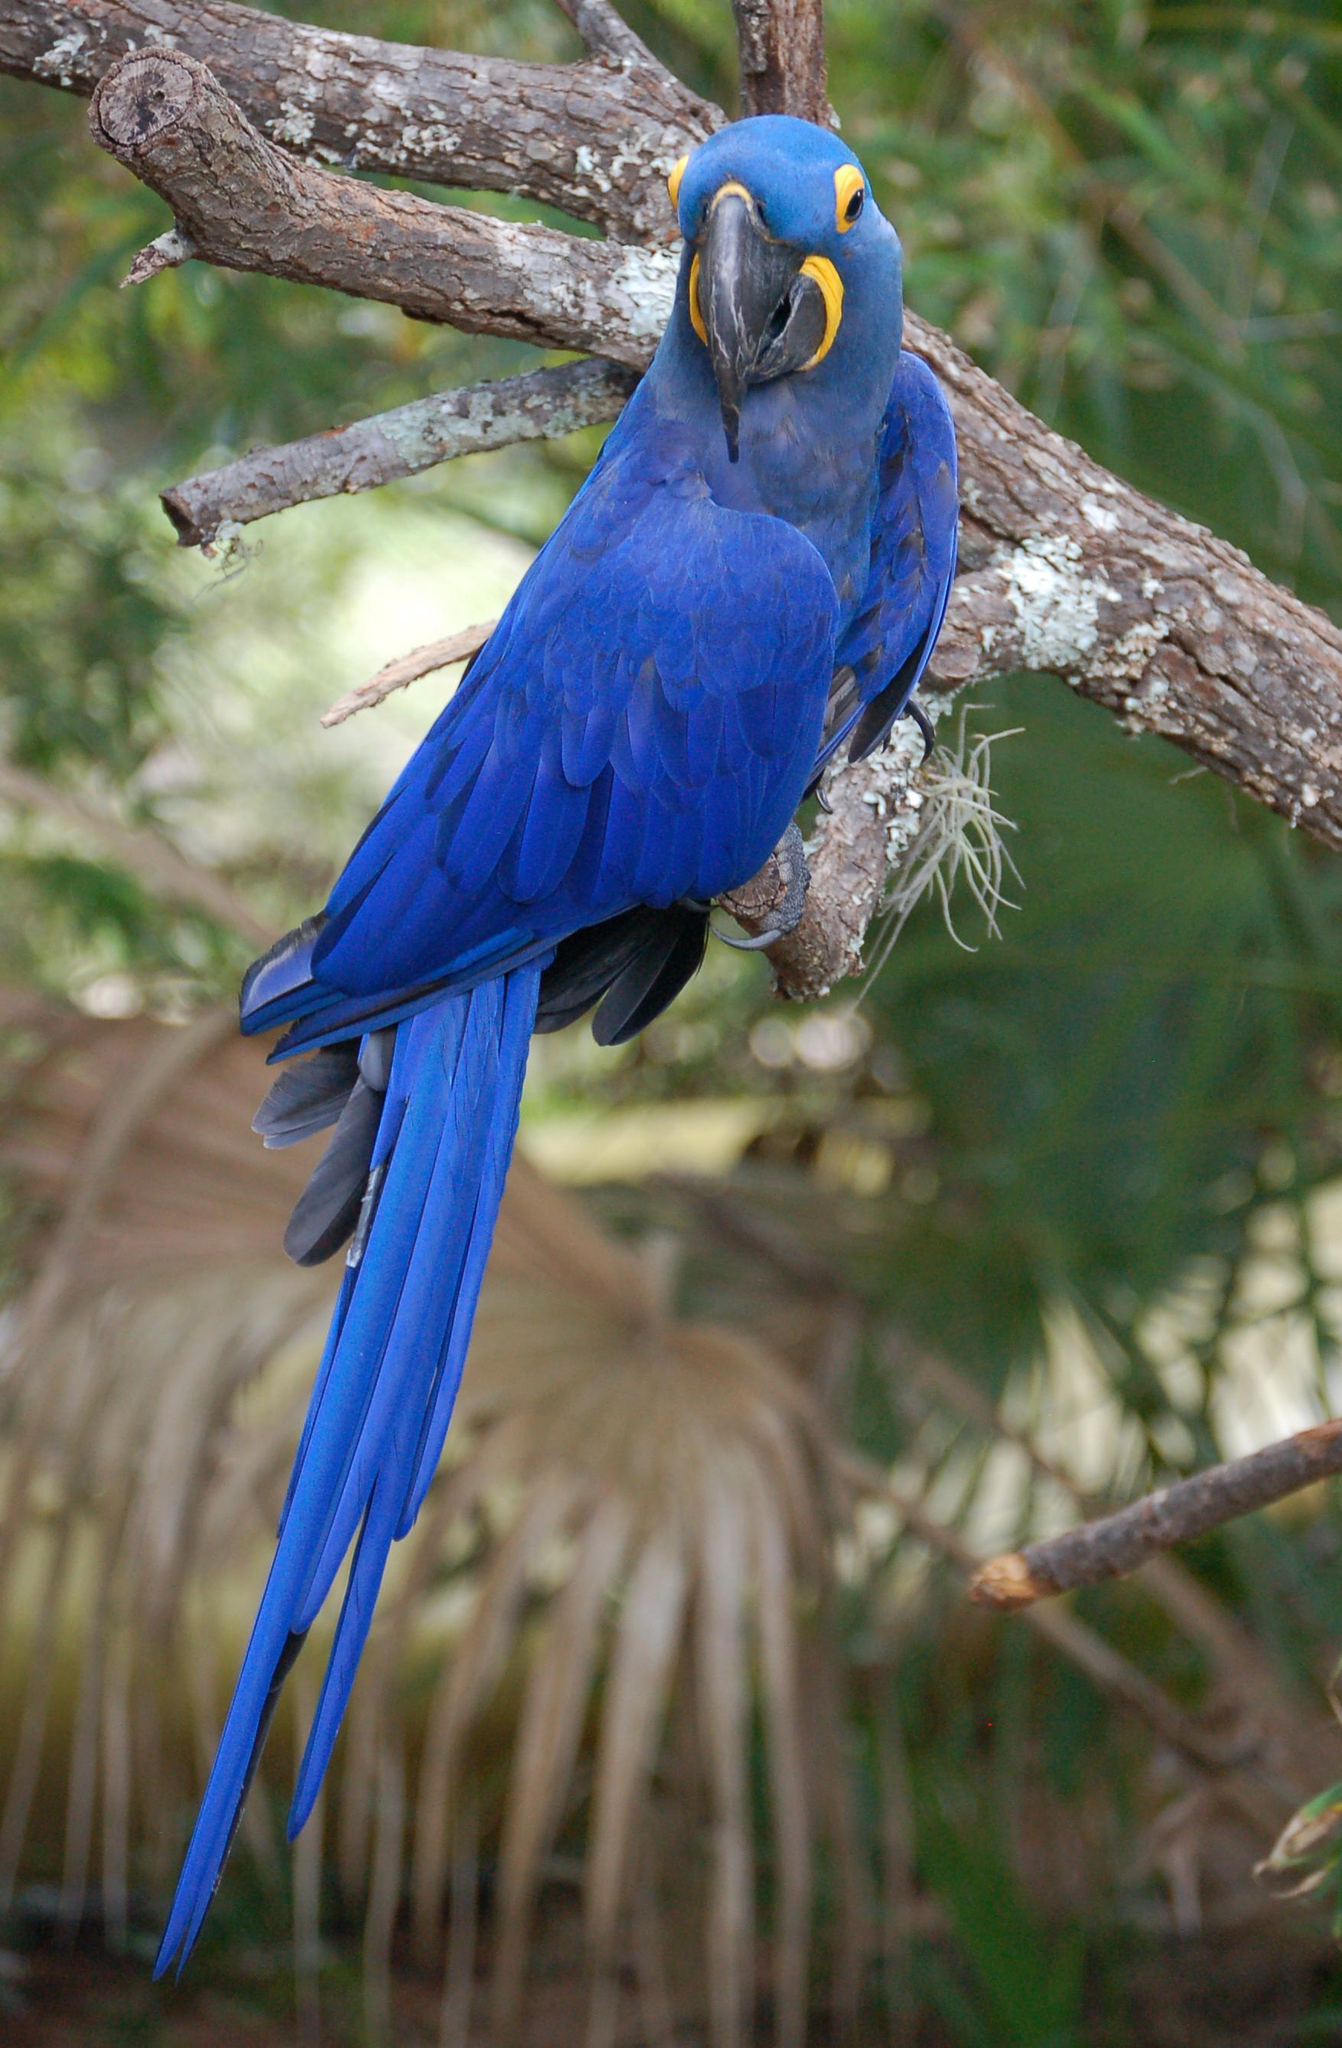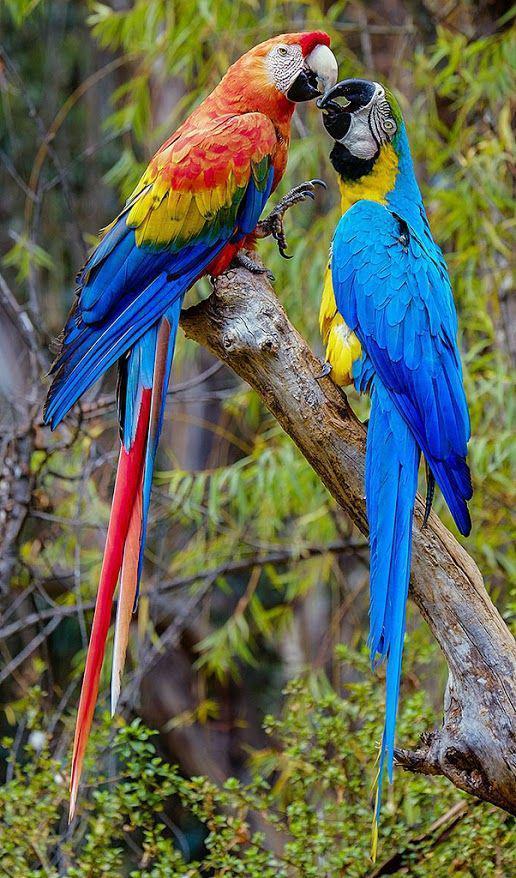The first image is the image on the left, the second image is the image on the right. Analyze the images presented: Is the assertion "One of the images contains exactly one parrot." valid? Answer yes or no. Yes. 